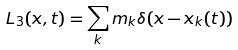<formula> <loc_0><loc_0><loc_500><loc_500>L _ { 3 } ( x , t ) = \sum _ { k } m _ { k } \delta ( x - x _ { k } ( t ) )</formula> 